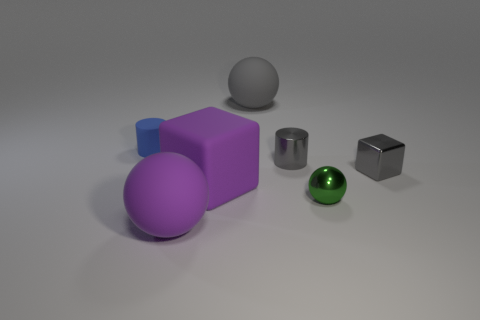What is the shape of the gray metal object that is on the right side of the green thing?
Keep it short and to the point. Cube. There is a gray shiny object to the left of the block to the right of the tiny shiny cylinder; is there a gray thing to the left of it?
Ensure brevity in your answer.  Yes. Are there any objects?
Make the answer very short. Yes. Is the cylinder that is on the right side of the purple matte block made of the same material as the purple thing in front of the green object?
Your answer should be compact. No. There is a rubber ball right of the purple object in front of the purple rubber thing that is behind the purple sphere; what size is it?
Your answer should be compact. Large. What number of tiny blocks have the same material as the tiny green object?
Provide a short and direct response. 1. Is the number of small metal cylinders less than the number of blue matte spheres?
Your response must be concise. No. There is a gray matte object that is the same shape as the small green object; what size is it?
Your answer should be compact. Large. Are the purple ball on the left side of the small green metal thing and the green object made of the same material?
Keep it short and to the point. No. Is the green metal object the same shape as the big gray matte object?
Give a very brief answer. Yes. 